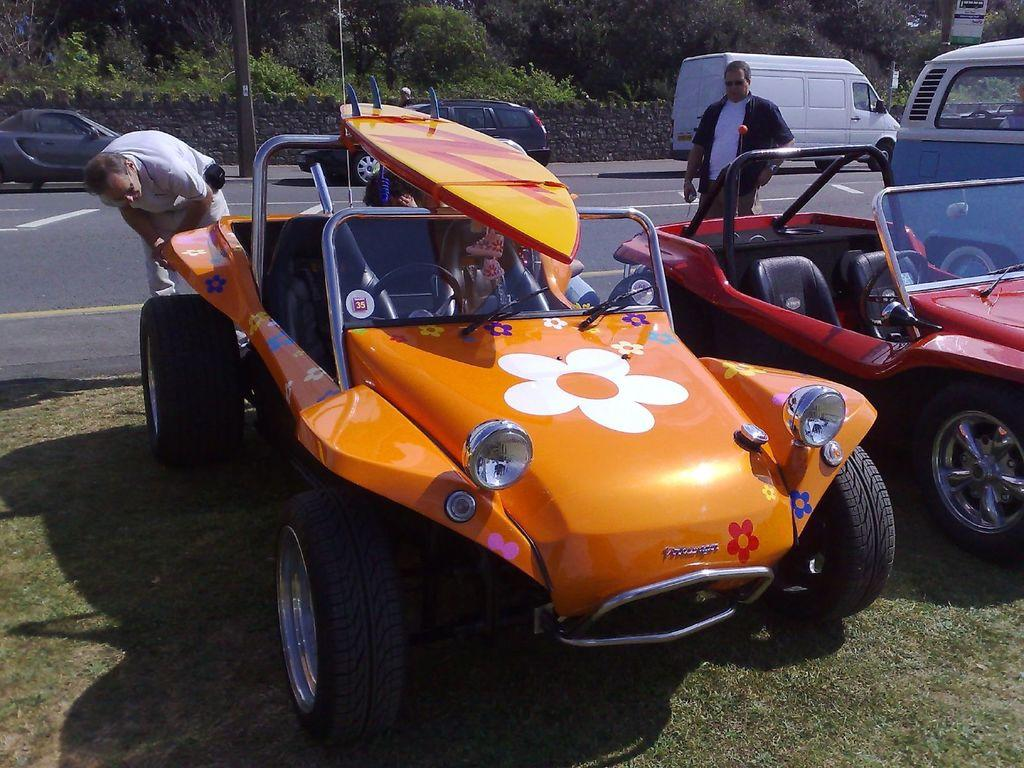What is located on the grass on the ground in the image? There are vehicles on the grass on the ground in the image. What can be seen in the background of the image? In the background, there are persons standing, vehicles on the road, poles, a wall, plants, trees, and hoardings}. Can you describe the vehicles on the road in the background? There are vehicles on the road in the background, but the image does not provide enough detail to describe them. How many servants are visible in the image? There are no servants present in the image. What action are the persons in the background performing? The image does not provide enough detail to determine the actions of the persons in the background. 